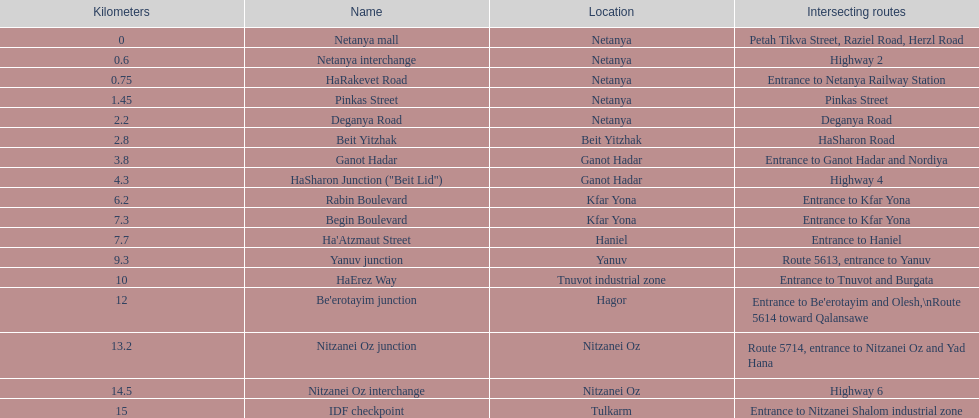What is the count of sections that meet highway 2? 1. 